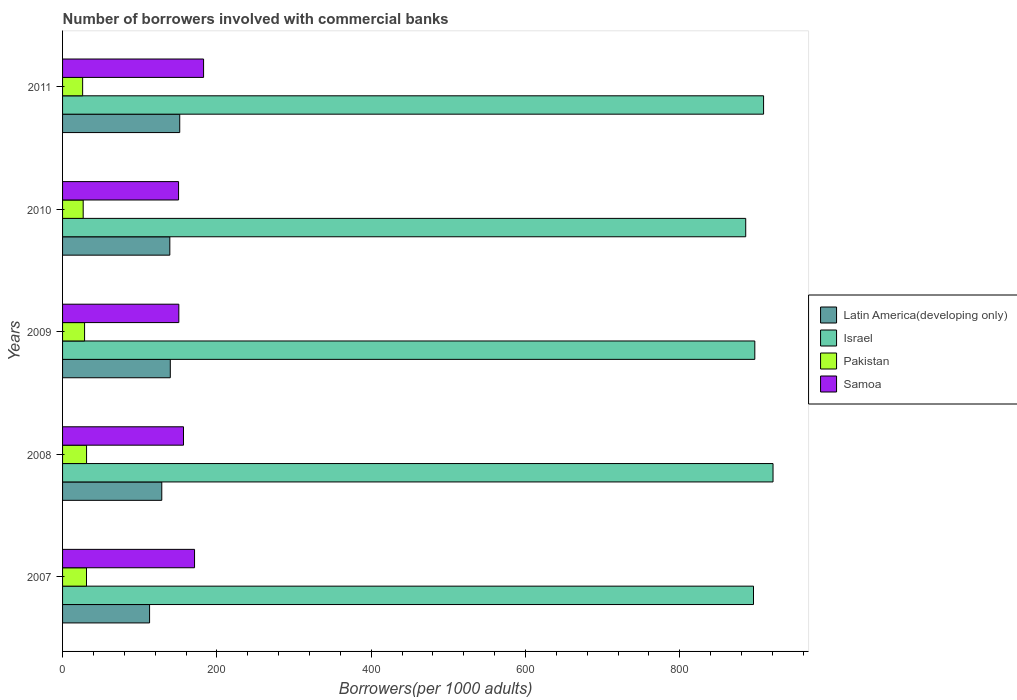How many different coloured bars are there?
Your answer should be very brief. 4. What is the label of the 3rd group of bars from the top?
Offer a very short reply. 2009. In how many cases, is the number of bars for a given year not equal to the number of legend labels?
Offer a very short reply. 0. What is the number of borrowers involved with commercial banks in Israel in 2011?
Ensure brevity in your answer.  908.52. Across all years, what is the maximum number of borrowers involved with commercial banks in Samoa?
Offer a very short reply. 182.76. Across all years, what is the minimum number of borrowers involved with commercial banks in Israel?
Keep it short and to the point. 885.37. In which year was the number of borrowers involved with commercial banks in Israel maximum?
Offer a very short reply. 2008. What is the total number of borrowers involved with commercial banks in Samoa in the graph?
Offer a terse response. 811.53. What is the difference between the number of borrowers involved with commercial banks in Samoa in 2007 and that in 2009?
Make the answer very short. 20.37. What is the difference between the number of borrowers involved with commercial banks in Pakistan in 2009 and the number of borrowers involved with commercial banks in Israel in 2008?
Offer a very short reply. -892.25. What is the average number of borrowers involved with commercial banks in Latin America(developing only) per year?
Make the answer very short. 134.37. In the year 2009, what is the difference between the number of borrowers involved with commercial banks in Samoa and number of borrowers involved with commercial banks in Israel?
Ensure brevity in your answer.  -746.48. In how many years, is the number of borrowers involved with commercial banks in Israel greater than 160 ?
Provide a short and direct response. 5. What is the ratio of the number of borrowers involved with commercial banks in Pakistan in 2007 to that in 2010?
Your response must be concise. 1.16. What is the difference between the highest and the second highest number of borrowers involved with commercial banks in Israel?
Provide a short and direct response. 12.25. What is the difference between the highest and the lowest number of borrowers involved with commercial banks in Pakistan?
Give a very brief answer. 5.08. Is the sum of the number of borrowers involved with commercial banks in Samoa in 2008 and 2010 greater than the maximum number of borrowers involved with commercial banks in Latin America(developing only) across all years?
Give a very brief answer. Yes. What does the 3rd bar from the top in 2008 represents?
Your answer should be very brief. Israel. What does the 1st bar from the bottom in 2009 represents?
Your response must be concise. Latin America(developing only). Are all the bars in the graph horizontal?
Ensure brevity in your answer.  Yes. How many years are there in the graph?
Your answer should be compact. 5. What is the difference between two consecutive major ticks on the X-axis?
Offer a very short reply. 200. Are the values on the major ticks of X-axis written in scientific E-notation?
Offer a very short reply. No. Does the graph contain grids?
Ensure brevity in your answer.  No. How are the legend labels stacked?
Offer a very short reply. Vertical. What is the title of the graph?
Offer a very short reply. Number of borrowers involved with commercial banks. What is the label or title of the X-axis?
Offer a very short reply. Borrowers(per 1000 adults). What is the Borrowers(per 1000 adults) in Latin America(developing only) in 2007?
Keep it short and to the point. 112.76. What is the Borrowers(per 1000 adults) of Israel in 2007?
Make the answer very short. 895.46. What is the Borrowers(per 1000 adults) in Pakistan in 2007?
Provide a succinct answer. 31.01. What is the Borrowers(per 1000 adults) of Samoa in 2007?
Keep it short and to the point. 171.04. What is the Borrowers(per 1000 adults) in Latin America(developing only) in 2008?
Make the answer very short. 128.58. What is the Borrowers(per 1000 adults) in Israel in 2008?
Your answer should be compact. 920.77. What is the Borrowers(per 1000 adults) in Pakistan in 2008?
Give a very brief answer. 31.09. What is the Borrowers(per 1000 adults) in Samoa in 2008?
Your answer should be compact. 156.73. What is the Borrowers(per 1000 adults) of Latin America(developing only) in 2009?
Ensure brevity in your answer.  139.62. What is the Borrowers(per 1000 adults) of Israel in 2009?
Keep it short and to the point. 897.16. What is the Borrowers(per 1000 adults) in Pakistan in 2009?
Ensure brevity in your answer.  28.52. What is the Borrowers(per 1000 adults) in Samoa in 2009?
Your response must be concise. 150.68. What is the Borrowers(per 1000 adults) of Latin America(developing only) in 2010?
Give a very brief answer. 139.02. What is the Borrowers(per 1000 adults) of Israel in 2010?
Give a very brief answer. 885.37. What is the Borrowers(per 1000 adults) in Pakistan in 2010?
Keep it short and to the point. 26.73. What is the Borrowers(per 1000 adults) in Samoa in 2010?
Keep it short and to the point. 150.32. What is the Borrowers(per 1000 adults) in Latin America(developing only) in 2011?
Ensure brevity in your answer.  151.85. What is the Borrowers(per 1000 adults) in Israel in 2011?
Keep it short and to the point. 908.52. What is the Borrowers(per 1000 adults) of Pakistan in 2011?
Ensure brevity in your answer.  26.01. What is the Borrowers(per 1000 adults) in Samoa in 2011?
Offer a very short reply. 182.76. Across all years, what is the maximum Borrowers(per 1000 adults) of Latin America(developing only)?
Your answer should be very brief. 151.85. Across all years, what is the maximum Borrowers(per 1000 adults) of Israel?
Your response must be concise. 920.77. Across all years, what is the maximum Borrowers(per 1000 adults) of Pakistan?
Provide a short and direct response. 31.09. Across all years, what is the maximum Borrowers(per 1000 adults) of Samoa?
Your answer should be compact. 182.76. Across all years, what is the minimum Borrowers(per 1000 adults) of Latin America(developing only)?
Provide a short and direct response. 112.76. Across all years, what is the minimum Borrowers(per 1000 adults) of Israel?
Keep it short and to the point. 885.37. Across all years, what is the minimum Borrowers(per 1000 adults) in Pakistan?
Provide a short and direct response. 26.01. Across all years, what is the minimum Borrowers(per 1000 adults) in Samoa?
Your response must be concise. 150.32. What is the total Borrowers(per 1000 adults) in Latin America(developing only) in the graph?
Offer a terse response. 671.83. What is the total Borrowers(per 1000 adults) of Israel in the graph?
Keep it short and to the point. 4507.28. What is the total Borrowers(per 1000 adults) of Pakistan in the graph?
Provide a short and direct response. 143.37. What is the total Borrowers(per 1000 adults) in Samoa in the graph?
Your answer should be very brief. 811.53. What is the difference between the Borrowers(per 1000 adults) of Latin America(developing only) in 2007 and that in 2008?
Ensure brevity in your answer.  -15.82. What is the difference between the Borrowers(per 1000 adults) of Israel in 2007 and that in 2008?
Give a very brief answer. -25.3. What is the difference between the Borrowers(per 1000 adults) of Pakistan in 2007 and that in 2008?
Provide a succinct answer. -0.08. What is the difference between the Borrowers(per 1000 adults) of Samoa in 2007 and that in 2008?
Give a very brief answer. 14.31. What is the difference between the Borrowers(per 1000 adults) in Latin America(developing only) in 2007 and that in 2009?
Your response must be concise. -26.86. What is the difference between the Borrowers(per 1000 adults) of Israel in 2007 and that in 2009?
Offer a very short reply. -1.7. What is the difference between the Borrowers(per 1000 adults) in Pakistan in 2007 and that in 2009?
Provide a short and direct response. 2.49. What is the difference between the Borrowers(per 1000 adults) in Samoa in 2007 and that in 2009?
Provide a short and direct response. 20.37. What is the difference between the Borrowers(per 1000 adults) of Latin America(developing only) in 2007 and that in 2010?
Offer a very short reply. -26.25. What is the difference between the Borrowers(per 1000 adults) of Israel in 2007 and that in 2010?
Provide a short and direct response. 10.09. What is the difference between the Borrowers(per 1000 adults) in Pakistan in 2007 and that in 2010?
Provide a succinct answer. 4.29. What is the difference between the Borrowers(per 1000 adults) of Samoa in 2007 and that in 2010?
Offer a very short reply. 20.72. What is the difference between the Borrowers(per 1000 adults) in Latin America(developing only) in 2007 and that in 2011?
Give a very brief answer. -39.08. What is the difference between the Borrowers(per 1000 adults) in Israel in 2007 and that in 2011?
Keep it short and to the point. -13.06. What is the difference between the Borrowers(per 1000 adults) of Pakistan in 2007 and that in 2011?
Give a very brief answer. 5.01. What is the difference between the Borrowers(per 1000 adults) of Samoa in 2007 and that in 2011?
Provide a short and direct response. -11.71. What is the difference between the Borrowers(per 1000 adults) of Latin America(developing only) in 2008 and that in 2009?
Make the answer very short. -11.04. What is the difference between the Borrowers(per 1000 adults) in Israel in 2008 and that in 2009?
Provide a short and direct response. 23.61. What is the difference between the Borrowers(per 1000 adults) in Pakistan in 2008 and that in 2009?
Your answer should be very brief. 2.57. What is the difference between the Borrowers(per 1000 adults) in Samoa in 2008 and that in 2009?
Your answer should be compact. 6.06. What is the difference between the Borrowers(per 1000 adults) of Latin America(developing only) in 2008 and that in 2010?
Provide a succinct answer. -10.43. What is the difference between the Borrowers(per 1000 adults) in Israel in 2008 and that in 2010?
Offer a terse response. 35.4. What is the difference between the Borrowers(per 1000 adults) in Pakistan in 2008 and that in 2010?
Keep it short and to the point. 4.36. What is the difference between the Borrowers(per 1000 adults) of Samoa in 2008 and that in 2010?
Your answer should be very brief. 6.41. What is the difference between the Borrowers(per 1000 adults) in Latin America(developing only) in 2008 and that in 2011?
Your answer should be very brief. -23.27. What is the difference between the Borrowers(per 1000 adults) in Israel in 2008 and that in 2011?
Your answer should be compact. 12.25. What is the difference between the Borrowers(per 1000 adults) of Pakistan in 2008 and that in 2011?
Your response must be concise. 5.08. What is the difference between the Borrowers(per 1000 adults) in Samoa in 2008 and that in 2011?
Provide a short and direct response. -26.02. What is the difference between the Borrowers(per 1000 adults) in Latin America(developing only) in 2009 and that in 2010?
Your answer should be compact. 0.61. What is the difference between the Borrowers(per 1000 adults) of Israel in 2009 and that in 2010?
Ensure brevity in your answer.  11.79. What is the difference between the Borrowers(per 1000 adults) in Pakistan in 2009 and that in 2010?
Your response must be concise. 1.79. What is the difference between the Borrowers(per 1000 adults) of Samoa in 2009 and that in 2010?
Ensure brevity in your answer.  0.35. What is the difference between the Borrowers(per 1000 adults) of Latin America(developing only) in 2009 and that in 2011?
Make the answer very short. -12.22. What is the difference between the Borrowers(per 1000 adults) of Israel in 2009 and that in 2011?
Provide a succinct answer. -11.36. What is the difference between the Borrowers(per 1000 adults) of Pakistan in 2009 and that in 2011?
Give a very brief answer. 2.51. What is the difference between the Borrowers(per 1000 adults) of Samoa in 2009 and that in 2011?
Your answer should be compact. -32.08. What is the difference between the Borrowers(per 1000 adults) in Latin America(developing only) in 2010 and that in 2011?
Your answer should be compact. -12.83. What is the difference between the Borrowers(per 1000 adults) of Israel in 2010 and that in 2011?
Your response must be concise. -23.15. What is the difference between the Borrowers(per 1000 adults) in Pakistan in 2010 and that in 2011?
Make the answer very short. 0.72. What is the difference between the Borrowers(per 1000 adults) in Samoa in 2010 and that in 2011?
Your answer should be compact. -32.43. What is the difference between the Borrowers(per 1000 adults) of Latin America(developing only) in 2007 and the Borrowers(per 1000 adults) of Israel in 2008?
Make the answer very short. -808.01. What is the difference between the Borrowers(per 1000 adults) of Latin America(developing only) in 2007 and the Borrowers(per 1000 adults) of Pakistan in 2008?
Your answer should be compact. 81.67. What is the difference between the Borrowers(per 1000 adults) of Latin America(developing only) in 2007 and the Borrowers(per 1000 adults) of Samoa in 2008?
Provide a short and direct response. -43.97. What is the difference between the Borrowers(per 1000 adults) of Israel in 2007 and the Borrowers(per 1000 adults) of Pakistan in 2008?
Give a very brief answer. 864.37. What is the difference between the Borrowers(per 1000 adults) of Israel in 2007 and the Borrowers(per 1000 adults) of Samoa in 2008?
Provide a short and direct response. 738.73. What is the difference between the Borrowers(per 1000 adults) in Pakistan in 2007 and the Borrowers(per 1000 adults) in Samoa in 2008?
Your answer should be compact. -125.72. What is the difference between the Borrowers(per 1000 adults) of Latin America(developing only) in 2007 and the Borrowers(per 1000 adults) of Israel in 2009?
Keep it short and to the point. -784.4. What is the difference between the Borrowers(per 1000 adults) of Latin America(developing only) in 2007 and the Borrowers(per 1000 adults) of Pakistan in 2009?
Offer a terse response. 84.24. What is the difference between the Borrowers(per 1000 adults) of Latin America(developing only) in 2007 and the Borrowers(per 1000 adults) of Samoa in 2009?
Make the answer very short. -37.91. What is the difference between the Borrowers(per 1000 adults) in Israel in 2007 and the Borrowers(per 1000 adults) in Pakistan in 2009?
Your answer should be very brief. 866.94. What is the difference between the Borrowers(per 1000 adults) of Israel in 2007 and the Borrowers(per 1000 adults) of Samoa in 2009?
Provide a short and direct response. 744.79. What is the difference between the Borrowers(per 1000 adults) of Pakistan in 2007 and the Borrowers(per 1000 adults) of Samoa in 2009?
Provide a succinct answer. -119.66. What is the difference between the Borrowers(per 1000 adults) of Latin America(developing only) in 2007 and the Borrowers(per 1000 adults) of Israel in 2010?
Offer a terse response. -772.61. What is the difference between the Borrowers(per 1000 adults) in Latin America(developing only) in 2007 and the Borrowers(per 1000 adults) in Pakistan in 2010?
Give a very brief answer. 86.03. What is the difference between the Borrowers(per 1000 adults) in Latin America(developing only) in 2007 and the Borrowers(per 1000 adults) in Samoa in 2010?
Provide a short and direct response. -37.56. What is the difference between the Borrowers(per 1000 adults) of Israel in 2007 and the Borrowers(per 1000 adults) of Pakistan in 2010?
Your answer should be compact. 868.74. What is the difference between the Borrowers(per 1000 adults) in Israel in 2007 and the Borrowers(per 1000 adults) in Samoa in 2010?
Your answer should be compact. 745.14. What is the difference between the Borrowers(per 1000 adults) in Pakistan in 2007 and the Borrowers(per 1000 adults) in Samoa in 2010?
Ensure brevity in your answer.  -119.31. What is the difference between the Borrowers(per 1000 adults) of Latin America(developing only) in 2007 and the Borrowers(per 1000 adults) of Israel in 2011?
Ensure brevity in your answer.  -795.76. What is the difference between the Borrowers(per 1000 adults) in Latin America(developing only) in 2007 and the Borrowers(per 1000 adults) in Pakistan in 2011?
Ensure brevity in your answer.  86.75. What is the difference between the Borrowers(per 1000 adults) of Latin America(developing only) in 2007 and the Borrowers(per 1000 adults) of Samoa in 2011?
Your answer should be compact. -69.99. What is the difference between the Borrowers(per 1000 adults) of Israel in 2007 and the Borrowers(per 1000 adults) of Pakistan in 2011?
Provide a succinct answer. 869.46. What is the difference between the Borrowers(per 1000 adults) in Israel in 2007 and the Borrowers(per 1000 adults) in Samoa in 2011?
Your answer should be very brief. 712.71. What is the difference between the Borrowers(per 1000 adults) in Pakistan in 2007 and the Borrowers(per 1000 adults) in Samoa in 2011?
Offer a very short reply. -151.74. What is the difference between the Borrowers(per 1000 adults) of Latin America(developing only) in 2008 and the Borrowers(per 1000 adults) of Israel in 2009?
Keep it short and to the point. -768.58. What is the difference between the Borrowers(per 1000 adults) of Latin America(developing only) in 2008 and the Borrowers(per 1000 adults) of Pakistan in 2009?
Your answer should be compact. 100.06. What is the difference between the Borrowers(per 1000 adults) of Latin America(developing only) in 2008 and the Borrowers(per 1000 adults) of Samoa in 2009?
Offer a terse response. -22.09. What is the difference between the Borrowers(per 1000 adults) of Israel in 2008 and the Borrowers(per 1000 adults) of Pakistan in 2009?
Provide a succinct answer. 892.25. What is the difference between the Borrowers(per 1000 adults) in Israel in 2008 and the Borrowers(per 1000 adults) in Samoa in 2009?
Your response must be concise. 770.09. What is the difference between the Borrowers(per 1000 adults) of Pakistan in 2008 and the Borrowers(per 1000 adults) of Samoa in 2009?
Keep it short and to the point. -119.58. What is the difference between the Borrowers(per 1000 adults) in Latin America(developing only) in 2008 and the Borrowers(per 1000 adults) in Israel in 2010?
Provide a short and direct response. -756.79. What is the difference between the Borrowers(per 1000 adults) in Latin America(developing only) in 2008 and the Borrowers(per 1000 adults) in Pakistan in 2010?
Make the answer very short. 101.85. What is the difference between the Borrowers(per 1000 adults) of Latin America(developing only) in 2008 and the Borrowers(per 1000 adults) of Samoa in 2010?
Provide a succinct answer. -21.74. What is the difference between the Borrowers(per 1000 adults) of Israel in 2008 and the Borrowers(per 1000 adults) of Pakistan in 2010?
Make the answer very short. 894.04. What is the difference between the Borrowers(per 1000 adults) of Israel in 2008 and the Borrowers(per 1000 adults) of Samoa in 2010?
Provide a short and direct response. 770.45. What is the difference between the Borrowers(per 1000 adults) in Pakistan in 2008 and the Borrowers(per 1000 adults) in Samoa in 2010?
Provide a succinct answer. -119.23. What is the difference between the Borrowers(per 1000 adults) of Latin America(developing only) in 2008 and the Borrowers(per 1000 adults) of Israel in 2011?
Your answer should be compact. -779.94. What is the difference between the Borrowers(per 1000 adults) of Latin America(developing only) in 2008 and the Borrowers(per 1000 adults) of Pakistan in 2011?
Offer a very short reply. 102.57. What is the difference between the Borrowers(per 1000 adults) of Latin America(developing only) in 2008 and the Borrowers(per 1000 adults) of Samoa in 2011?
Offer a terse response. -54.18. What is the difference between the Borrowers(per 1000 adults) of Israel in 2008 and the Borrowers(per 1000 adults) of Pakistan in 2011?
Make the answer very short. 894.76. What is the difference between the Borrowers(per 1000 adults) of Israel in 2008 and the Borrowers(per 1000 adults) of Samoa in 2011?
Offer a terse response. 738.01. What is the difference between the Borrowers(per 1000 adults) in Pakistan in 2008 and the Borrowers(per 1000 adults) in Samoa in 2011?
Offer a very short reply. -151.67. What is the difference between the Borrowers(per 1000 adults) of Latin America(developing only) in 2009 and the Borrowers(per 1000 adults) of Israel in 2010?
Offer a very short reply. -745.75. What is the difference between the Borrowers(per 1000 adults) of Latin America(developing only) in 2009 and the Borrowers(per 1000 adults) of Pakistan in 2010?
Offer a very short reply. 112.89. What is the difference between the Borrowers(per 1000 adults) in Latin America(developing only) in 2009 and the Borrowers(per 1000 adults) in Samoa in 2010?
Give a very brief answer. -10.7. What is the difference between the Borrowers(per 1000 adults) of Israel in 2009 and the Borrowers(per 1000 adults) of Pakistan in 2010?
Your answer should be very brief. 870.43. What is the difference between the Borrowers(per 1000 adults) in Israel in 2009 and the Borrowers(per 1000 adults) in Samoa in 2010?
Keep it short and to the point. 746.84. What is the difference between the Borrowers(per 1000 adults) in Pakistan in 2009 and the Borrowers(per 1000 adults) in Samoa in 2010?
Your response must be concise. -121.8. What is the difference between the Borrowers(per 1000 adults) in Latin America(developing only) in 2009 and the Borrowers(per 1000 adults) in Israel in 2011?
Provide a succinct answer. -768.9. What is the difference between the Borrowers(per 1000 adults) of Latin America(developing only) in 2009 and the Borrowers(per 1000 adults) of Pakistan in 2011?
Provide a short and direct response. 113.61. What is the difference between the Borrowers(per 1000 adults) of Latin America(developing only) in 2009 and the Borrowers(per 1000 adults) of Samoa in 2011?
Give a very brief answer. -43.13. What is the difference between the Borrowers(per 1000 adults) of Israel in 2009 and the Borrowers(per 1000 adults) of Pakistan in 2011?
Ensure brevity in your answer.  871.15. What is the difference between the Borrowers(per 1000 adults) of Israel in 2009 and the Borrowers(per 1000 adults) of Samoa in 2011?
Make the answer very short. 714.4. What is the difference between the Borrowers(per 1000 adults) in Pakistan in 2009 and the Borrowers(per 1000 adults) in Samoa in 2011?
Offer a very short reply. -154.24. What is the difference between the Borrowers(per 1000 adults) in Latin America(developing only) in 2010 and the Borrowers(per 1000 adults) in Israel in 2011?
Your answer should be compact. -769.51. What is the difference between the Borrowers(per 1000 adults) of Latin America(developing only) in 2010 and the Borrowers(per 1000 adults) of Pakistan in 2011?
Give a very brief answer. 113.01. What is the difference between the Borrowers(per 1000 adults) in Latin America(developing only) in 2010 and the Borrowers(per 1000 adults) in Samoa in 2011?
Offer a terse response. -43.74. What is the difference between the Borrowers(per 1000 adults) in Israel in 2010 and the Borrowers(per 1000 adults) in Pakistan in 2011?
Your answer should be compact. 859.36. What is the difference between the Borrowers(per 1000 adults) in Israel in 2010 and the Borrowers(per 1000 adults) in Samoa in 2011?
Offer a very short reply. 702.61. What is the difference between the Borrowers(per 1000 adults) of Pakistan in 2010 and the Borrowers(per 1000 adults) of Samoa in 2011?
Provide a short and direct response. -156.03. What is the average Borrowers(per 1000 adults) in Latin America(developing only) per year?
Your response must be concise. 134.37. What is the average Borrowers(per 1000 adults) in Israel per year?
Provide a succinct answer. 901.46. What is the average Borrowers(per 1000 adults) in Pakistan per year?
Make the answer very short. 28.67. What is the average Borrowers(per 1000 adults) of Samoa per year?
Keep it short and to the point. 162.31. In the year 2007, what is the difference between the Borrowers(per 1000 adults) in Latin America(developing only) and Borrowers(per 1000 adults) in Israel?
Your response must be concise. -782.7. In the year 2007, what is the difference between the Borrowers(per 1000 adults) in Latin America(developing only) and Borrowers(per 1000 adults) in Pakistan?
Your answer should be very brief. 81.75. In the year 2007, what is the difference between the Borrowers(per 1000 adults) in Latin America(developing only) and Borrowers(per 1000 adults) in Samoa?
Keep it short and to the point. -58.28. In the year 2007, what is the difference between the Borrowers(per 1000 adults) of Israel and Borrowers(per 1000 adults) of Pakistan?
Offer a terse response. 864.45. In the year 2007, what is the difference between the Borrowers(per 1000 adults) in Israel and Borrowers(per 1000 adults) in Samoa?
Provide a succinct answer. 724.42. In the year 2007, what is the difference between the Borrowers(per 1000 adults) in Pakistan and Borrowers(per 1000 adults) in Samoa?
Keep it short and to the point. -140.03. In the year 2008, what is the difference between the Borrowers(per 1000 adults) of Latin America(developing only) and Borrowers(per 1000 adults) of Israel?
Your answer should be very brief. -792.19. In the year 2008, what is the difference between the Borrowers(per 1000 adults) in Latin America(developing only) and Borrowers(per 1000 adults) in Pakistan?
Give a very brief answer. 97.49. In the year 2008, what is the difference between the Borrowers(per 1000 adults) in Latin America(developing only) and Borrowers(per 1000 adults) in Samoa?
Provide a short and direct response. -28.15. In the year 2008, what is the difference between the Borrowers(per 1000 adults) in Israel and Borrowers(per 1000 adults) in Pakistan?
Give a very brief answer. 889.68. In the year 2008, what is the difference between the Borrowers(per 1000 adults) in Israel and Borrowers(per 1000 adults) in Samoa?
Ensure brevity in your answer.  764.03. In the year 2008, what is the difference between the Borrowers(per 1000 adults) of Pakistan and Borrowers(per 1000 adults) of Samoa?
Offer a very short reply. -125.64. In the year 2009, what is the difference between the Borrowers(per 1000 adults) in Latin America(developing only) and Borrowers(per 1000 adults) in Israel?
Provide a succinct answer. -757.54. In the year 2009, what is the difference between the Borrowers(per 1000 adults) in Latin America(developing only) and Borrowers(per 1000 adults) in Pakistan?
Provide a succinct answer. 111.1. In the year 2009, what is the difference between the Borrowers(per 1000 adults) in Latin America(developing only) and Borrowers(per 1000 adults) in Samoa?
Offer a terse response. -11.05. In the year 2009, what is the difference between the Borrowers(per 1000 adults) in Israel and Borrowers(per 1000 adults) in Pakistan?
Your answer should be compact. 868.64. In the year 2009, what is the difference between the Borrowers(per 1000 adults) of Israel and Borrowers(per 1000 adults) of Samoa?
Keep it short and to the point. 746.48. In the year 2009, what is the difference between the Borrowers(per 1000 adults) in Pakistan and Borrowers(per 1000 adults) in Samoa?
Your answer should be compact. -122.15. In the year 2010, what is the difference between the Borrowers(per 1000 adults) of Latin America(developing only) and Borrowers(per 1000 adults) of Israel?
Provide a succinct answer. -746.35. In the year 2010, what is the difference between the Borrowers(per 1000 adults) in Latin America(developing only) and Borrowers(per 1000 adults) in Pakistan?
Your answer should be compact. 112.29. In the year 2010, what is the difference between the Borrowers(per 1000 adults) of Latin America(developing only) and Borrowers(per 1000 adults) of Samoa?
Give a very brief answer. -11.31. In the year 2010, what is the difference between the Borrowers(per 1000 adults) in Israel and Borrowers(per 1000 adults) in Pakistan?
Offer a very short reply. 858.64. In the year 2010, what is the difference between the Borrowers(per 1000 adults) of Israel and Borrowers(per 1000 adults) of Samoa?
Offer a terse response. 735.05. In the year 2010, what is the difference between the Borrowers(per 1000 adults) of Pakistan and Borrowers(per 1000 adults) of Samoa?
Offer a terse response. -123.59. In the year 2011, what is the difference between the Borrowers(per 1000 adults) in Latin America(developing only) and Borrowers(per 1000 adults) in Israel?
Give a very brief answer. -756.67. In the year 2011, what is the difference between the Borrowers(per 1000 adults) in Latin America(developing only) and Borrowers(per 1000 adults) in Pakistan?
Give a very brief answer. 125.84. In the year 2011, what is the difference between the Borrowers(per 1000 adults) in Latin America(developing only) and Borrowers(per 1000 adults) in Samoa?
Keep it short and to the point. -30.91. In the year 2011, what is the difference between the Borrowers(per 1000 adults) in Israel and Borrowers(per 1000 adults) in Pakistan?
Give a very brief answer. 882.51. In the year 2011, what is the difference between the Borrowers(per 1000 adults) of Israel and Borrowers(per 1000 adults) of Samoa?
Give a very brief answer. 725.76. In the year 2011, what is the difference between the Borrowers(per 1000 adults) in Pakistan and Borrowers(per 1000 adults) in Samoa?
Provide a short and direct response. -156.75. What is the ratio of the Borrowers(per 1000 adults) of Latin America(developing only) in 2007 to that in 2008?
Give a very brief answer. 0.88. What is the ratio of the Borrowers(per 1000 adults) of Israel in 2007 to that in 2008?
Offer a very short reply. 0.97. What is the ratio of the Borrowers(per 1000 adults) of Samoa in 2007 to that in 2008?
Make the answer very short. 1.09. What is the ratio of the Borrowers(per 1000 adults) of Latin America(developing only) in 2007 to that in 2009?
Keep it short and to the point. 0.81. What is the ratio of the Borrowers(per 1000 adults) in Israel in 2007 to that in 2009?
Provide a succinct answer. 1. What is the ratio of the Borrowers(per 1000 adults) in Pakistan in 2007 to that in 2009?
Your answer should be compact. 1.09. What is the ratio of the Borrowers(per 1000 adults) of Samoa in 2007 to that in 2009?
Your answer should be very brief. 1.14. What is the ratio of the Borrowers(per 1000 adults) of Latin America(developing only) in 2007 to that in 2010?
Offer a terse response. 0.81. What is the ratio of the Borrowers(per 1000 adults) in Israel in 2007 to that in 2010?
Offer a very short reply. 1.01. What is the ratio of the Borrowers(per 1000 adults) in Pakistan in 2007 to that in 2010?
Your answer should be very brief. 1.16. What is the ratio of the Borrowers(per 1000 adults) in Samoa in 2007 to that in 2010?
Give a very brief answer. 1.14. What is the ratio of the Borrowers(per 1000 adults) of Latin America(developing only) in 2007 to that in 2011?
Provide a short and direct response. 0.74. What is the ratio of the Borrowers(per 1000 adults) in Israel in 2007 to that in 2011?
Keep it short and to the point. 0.99. What is the ratio of the Borrowers(per 1000 adults) in Pakistan in 2007 to that in 2011?
Make the answer very short. 1.19. What is the ratio of the Borrowers(per 1000 adults) in Samoa in 2007 to that in 2011?
Keep it short and to the point. 0.94. What is the ratio of the Borrowers(per 1000 adults) of Latin America(developing only) in 2008 to that in 2009?
Your answer should be compact. 0.92. What is the ratio of the Borrowers(per 1000 adults) of Israel in 2008 to that in 2009?
Your answer should be compact. 1.03. What is the ratio of the Borrowers(per 1000 adults) of Pakistan in 2008 to that in 2009?
Offer a very short reply. 1.09. What is the ratio of the Borrowers(per 1000 adults) in Samoa in 2008 to that in 2009?
Your response must be concise. 1.04. What is the ratio of the Borrowers(per 1000 adults) of Latin America(developing only) in 2008 to that in 2010?
Your answer should be very brief. 0.92. What is the ratio of the Borrowers(per 1000 adults) in Israel in 2008 to that in 2010?
Keep it short and to the point. 1.04. What is the ratio of the Borrowers(per 1000 adults) of Pakistan in 2008 to that in 2010?
Make the answer very short. 1.16. What is the ratio of the Borrowers(per 1000 adults) of Samoa in 2008 to that in 2010?
Your answer should be compact. 1.04. What is the ratio of the Borrowers(per 1000 adults) in Latin America(developing only) in 2008 to that in 2011?
Your answer should be compact. 0.85. What is the ratio of the Borrowers(per 1000 adults) in Israel in 2008 to that in 2011?
Your answer should be very brief. 1.01. What is the ratio of the Borrowers(per 1000 adults) of Pakistan in 2008 to that in 2011?
Give a very brief answer. 1.2. What is the ratio of the Borrowers(per 1000 adults) in Samoa in 2008 to that in 2011?
Ensure brevity in your answer.  0.86. What is the ratio of the Borrowers(per 1000 adults) in Latin America(developing only) in 2009 to that in 2010?
Provide a short and direct response. 1. What is the ratio of the Borrowers(per 1000 adults) of Israel in 2009 to that in 2010?
Offer a terse response. 1.01. What is the ratio of the Borrowers(per 1000 adults) of Pakistan in 2009 to that in 2010?
Your answer should be compact. 1.07. What is the ratio of the Borrowers(per 1000 adults) in Samoa in 2009 to that in 2010?
Give a very brief answer. 1. What is the ratio of the Borrowers(per 1000 adults) of Latin America(developing only) in 2009 to that in 2011?
Your answer should be compact. 0.92. What is the ratio of the Borrowers(per 1000 adults) of Israel in 2009 to that in 2011?
Ensure brevity in your answer.  0.99. What is the ratio of the Borrowers(per 1000 adults) in Pakistan in 2009 to that in 2011?
Keep it short and to the point. 1.1. What is the ratio of the Borrowers(per 1000 adults) of Samoa in 2009 to that in 2011?
Keep it short and to the point. 0.82. What is the ratio of the Borrowers(per 1000 adults) in Latin America(developing only) in 2010 to that in 2011?
Give a very brief answer. 0.92. What is the ratio of the Borrowers(per 1000 adults) of Israel in 2010 to that in 2011?
Ensure brevity in your answer.  0.97. What is the ratio of the Borrowers(per 1000 adults) of Pakistan in 2010 to that in 2011?
Give a very brief answer. 1.03. What is the ratio of the Borrowers(per 1000 adults) in Samoa in 2010 to that in 2011?
Provide a short and direct response. 0.82. What is the difference between the highest and the second highest Borrowers(per 1000 adults) of Latin America(developing only)?
Provide a short and direct response. 12.22. What is the difference between the highest and the second highest Borrowers(per 1000 adults) of Israel?
Your response must be concise. 12.25. What is the difference between the highest and the second highest Borrowers(per 1000 adults) in Pakistan?
Offer a terse response. 0.08. What is the difference between the highest and the second highest Borrowers(per 1000 adults) of Samoa?
Provide a short and direct response. 11.71. What is the difference between the highest and the lowest Borrowers(per 1000 adults) in Latin America(developing only)?
Your answer should be compact. 39.08. What is the difference between the highest and the lowest Borrowers(per 1000 adults) in Israel?
Your answer should be compact. 35.4. What is the difference between the highest and the lowest Borrowers(per 1000 adults) in Pakistan?
Make the answer very short. 5.08. What is the difference between the highest and the lowest Borrowers(per 1000 adults) in Samoa?
Offer a very short reply. 32.43. 